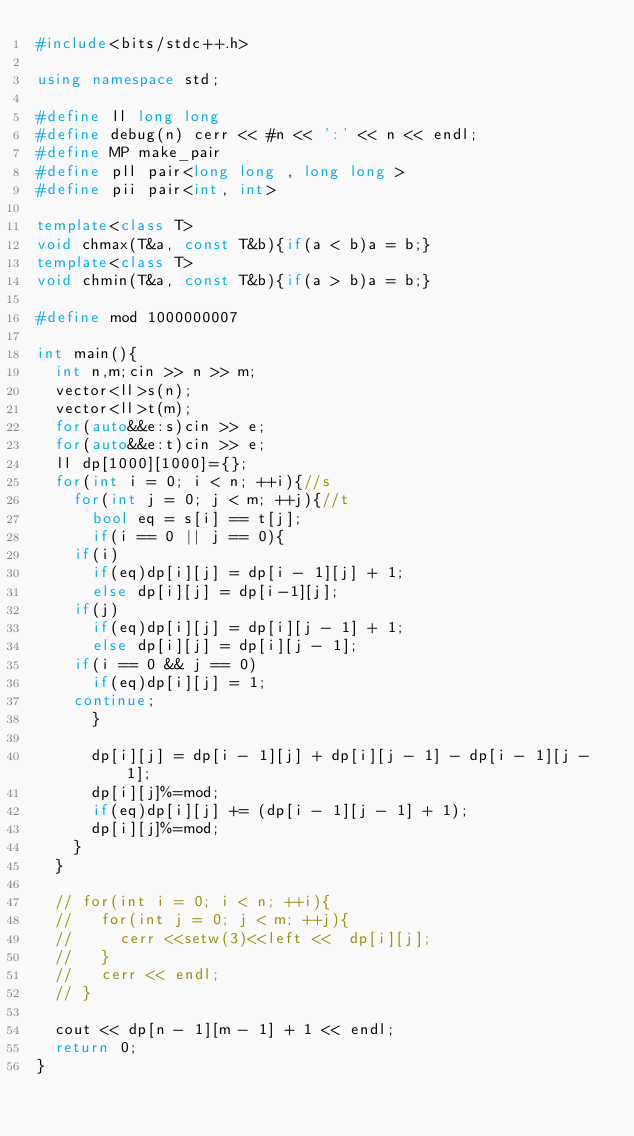Convert code to text. <code><loc_0><loc_0><loc_500><loc_500><_C++_>#include<bits/stdc++.h>

using namespace std;

#define ll long long
#define debug(n) cerr << #n << ':' << n << endl;
#define MP make_pair
#define pll pair<long long , long long >
#define pii pair<int, int>

template<class T>
void chmax(T&a, const T&b){if(a < b)a = b;}
template<class T>
void chmin(T&a, const T&b){if(a > b)a = b;}

#define mod 1000000007

int main(){
  int n,m;cin >> n >> m;
  vector<ll>s(n);
  vector<ll>t(m);
  for(auto&&e:s)cin >> e;
  for(auto&&e:t)cin >> e;
  ll dp[1000][1000]={};
  for(int i = 0; i < n; ++i){//s
    for(int j = 0; j < m; ++j){//t
      bool eq = s[i] == t[j];
      if(i == 0 || j == 0){
	if(i)
	  if(eq)dp[i][j] = dp[i - 1][j] + 1;
	  else dp[i][j] = dp[i-1][j];
	if(j)
	  if(eq)dp[i][j] = dp[i][j - 1] + 1;
	  else dp[i][j] = dp[i][j - 1];
	if(i == 0 && j == 0)
	  if(eq)dp[i][j] = 1;
	continue;
      }

      dp[i][j] = dp[i - 1][j] + dp[i][j - 1] - dp[i - 1][j - 1];
      dp[i][j]%=mod;      
      if(eq)dp[i][j] += (dp[i - 1][j - 1] + 1);
      dp[i][j]%=mod;      
    }
  }

  // for(int i = 0; i < n; ++i){
  //   for(int j = 0; j < m; ++j){
  //     cerr <<setw(3)<<left <<  dp[i][j];
  //   }
  //   cerr << endl;
  // }
  
  cout << dp[n - 1][m - 1] + 1 << endl;
  return 0;
}
</code> 